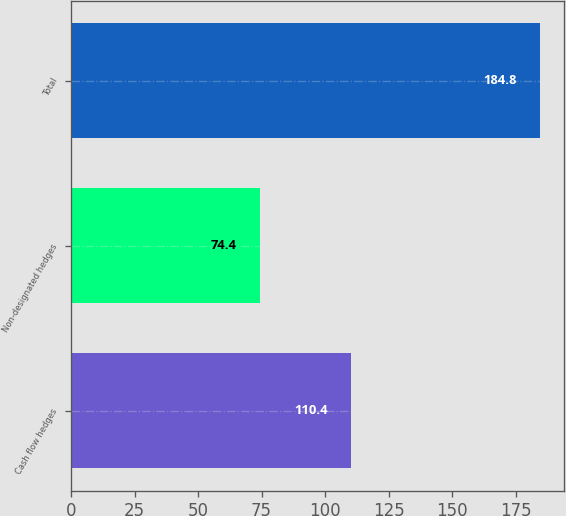<chart> <loc_0><loc_0><loc_500><loc_500><bar_chart><fcel>Cash flow hedges<fcel>Non-designated hedges<fcel>Total<nl><fcel>110.4<fcel>74.4<fcel>184.8<nl></chart> 